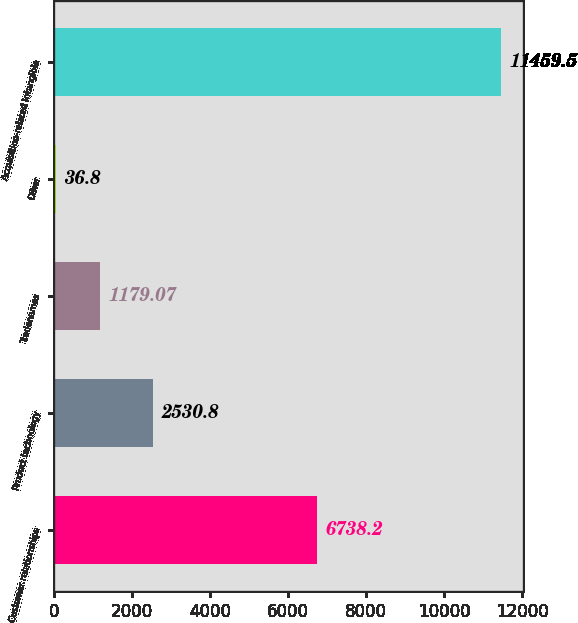<chart> <loc_0><loc_0><loc_500><loc_500><bar_chart><fcel>Customer relationships<fcel>Product technology<fcel>Tradenames<fcel>Other<fcel>Acquisition-related Intangible<nl><fcel>6738.2<fcel>2530.8<fcel>1179.07<fcel>36.8<fcel>11459.5<nl></chart> 